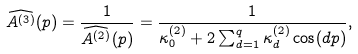<formula> <loc_0><loc_0><loc_500><loc_500>\widehat { A ^ { ( 3 ) } } ( p ) = \frac { 1 } { \widehat { A ^ { ( 2 ) } } ( p ) } = \frac { 1 } { \kappa ^ { ( 2 ) } _ { 0 } + 2 \sum _ { d = 1 } ^ { q } \kappa ^ { ( 2 ) } _ { d } \cos ( d p ) } ,</formula> 